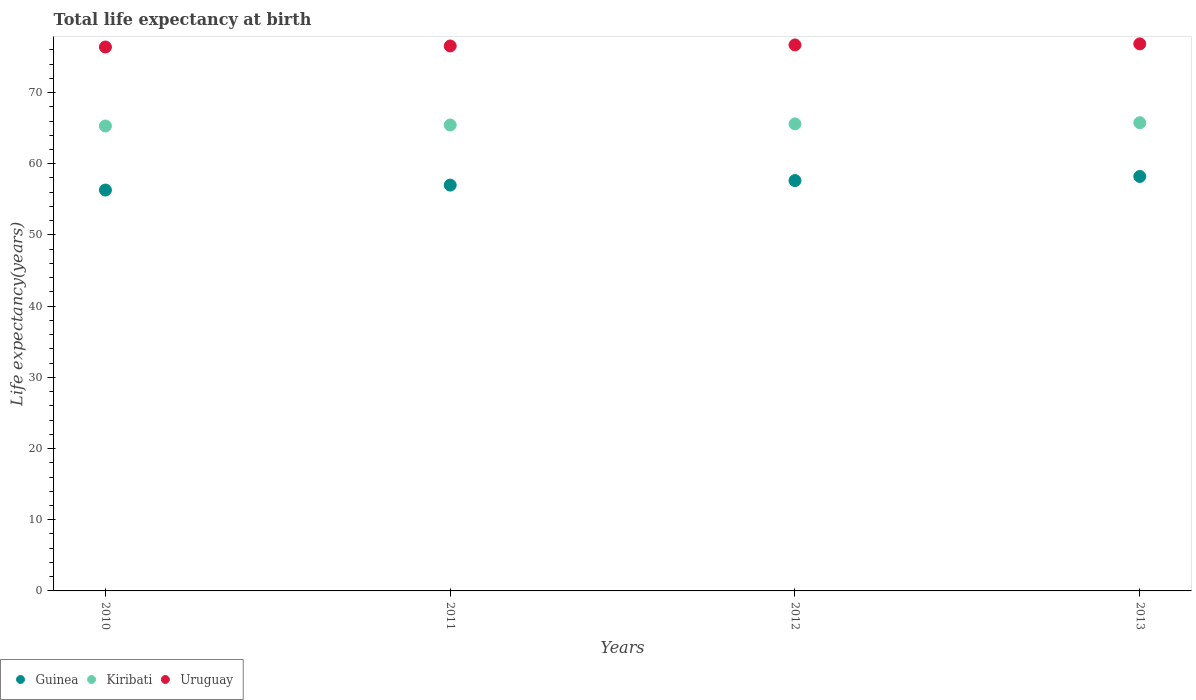What is the life expectancy at birth in in Guinea in 2012?
Make the answer very short. 57.64. Across all years, what is the maximum life expectancy at birth in in Kiribati?
Your answer should be compact. 65.77. Across all years, what is the minimum life expectancy at birth in in Uruguay?
Offer a very short reply. 76.39. In which year was the life expectancy at birth in in Guinea minimum?
Your answer should be compact. 2010. What is the total life expectancy at birth in in Uruguay in the graph?
Your answer should be very brief. 306.46. What is the difference between the life expectancy at birth in in Kiribati in 2010 and that in 2013?
Make the answer very short. -0.46. What is the difference between the life expectancy at birth in in Kiribati in 2011 and the life expectancy at birth in in Uruguay in 2013?
Make the answer very short. -11.4. What is the average life expectancy at birth in in Kiribati per year?
Offer a very short reply. 65.53. In the year 2012, what is the difference between the life expectancy at birth in in Kiribati and life expectancy at birth in in Guinea?
Your answer should be very brief. 7.96. In how many years, is the life expectancy at birth in in Guinea greater than 50 years?
Your response must be concise. 4. What is the ratio of the life expectancy at birth in in Uruguay in 2012 to that in 2013?
Give a very brief answer. 1. Is the life expectancy at birth in in Uruguay in 2012 less than that in 2013?
Your answer should be compact. Yes. What is the difference between the highest and the second highest life expectancy at birth in in Guinea?
Give a very brief answer. 0.58. What is the difference between the highest and the lowest life expectancy at birth in in Uruguay?
Ensure brevity in your answer.  0.44. Is the sum of the life expectancy at birth in in Kiribati in 2010 and 2012 greater than the maximum life expectancy at birth in in Uruguay across all years?
Provide a short and direct response. Yes. How many dotlines are there?
Ensure brevity in your answer.  3. How many years are there in the graph?
Give a very brief answer. 4. What is the difference between two consecutive major ticks on the Y-axis?
Offer a very short reply. 10. Does the graph contain grids?
Offer a very short reply. No. Where does the legend appear in the graph?
Offer a very short reply. Bottom left. How many legend labels are there?
Offer a terse response. 3. How are the legend labels stacked?
Make the answer very short. Horizontal. What is the title of the graph?
Make the answer very short. Total life expectancy at birth. What is the label or title of the Y-axis?
Offer a terse response. Life expectancy(years). What is the Life expectancy(years) in Guinea in 2010?
Your answer should be compact. 56.31. What is the Life expectancy(years) of Kiribati in 2010?
Give a very brief answer. 65.3. What is the Life expectancy(years) of Uruguay in 2010?
Provide a succinct answer. 76.39. What is the Life expectancy(years) in Guinea in 2011?
Your answer should be compact. 57. What is the Life expectancy(years) in Kiribati in 2011?
Keep it short and to the point. 65.44. What is the Life expectancy(years) of Uruguay in 2011?
Make the answer very short. 76.54. What is the Life expectancy(years) in Guinea in 2012?
Provide a short and direct response. 57.64. What is the Life expectancy(years) of Kiribati in 2012?
Your answer should be very brief. 65.6. What is the Life expectancy(years) of Uruguay in 2012?
Ensure brevity in your answer.  76.69. What is the Life expectancy(years) in Guinea in 2013?
Give a very brief answer. 58.22. What is the Life expectancy(years) of Kiribati in 2013?
Offer a terse response. 65.77. What is the Life expectancy(years) of Uruguay in 2013?
Offer a terse response. 76.84. Across all years, what is the maximum Life expectancy(years) in Guinea?
Give a very brief answer. 58.22. Across all years, what is the maximum Life expectancy(years) of Kiribati?
Provide a succinct answer. 65.77. Across all years, what is the maximum Life expectancy(years) of Uruguay?
Your answer should be compact. 76.84. Across all years, what is the minimum Life expectancy(years) in Guinea?
Ensure brevity in your answer.  56.31. Across all years, what is the minimum Life expectancy(years) of Kiribati?
Provide a succinct answer. 65.3. Across all years, what is the minimum Life expectancy(years) in Uruguay?
Provide a short and direct response. 76.39. What is the total Life expectancy(years) of Guinea in the graph?
Provide a succinct answer. 229.16. What is the total Life expectancy(years) of Kiribati in the graph?
Your answer should be very brief. 262.11. What is the total Life expectancy(years) of Uruguay in the graph?
Offer a terse response. 306.46. What is the difference between the Life expectancy(years) of Guinea in 2010 and that in 2011?
Make the answer very short. -0.7. What is the difference between the Life expectancy(years) of Kiribati in 2010 and that in 2011?
Your answer should be compact. -0.14. What is the difference between the Life expectancy(years) of Uruguay in 2010 and that in 2011?
Your answer should be very brief. -0.15. What is the difference between the Life expectancy(years) of Guinea in 2010 and that in 2012?
Your response must be concise. -1.33. What is the difference between the Life expectancy(years) of Kiribati in 2010 and that in 2012?
Ensure brevity in your answer.  -0.29. What is the difference between the Life expectancy(years) of Uruguay in 2010 and that in 2012?
Your answer should be compact. -0.29. What is the difference between the Life expectancy(years) in Guinea in 2010 and that in 2013?
Offer a very short reply. -1.91. What is the difference between the Life expectancy(years) of Kiribati in 2010 and that in 2013?
Your response must be concise. -0.46. What is the difference between the Life expectancy(years) of Uruguay in 2010 and that in 2013?
Your answer should be compact. -0.44. What is the difference between the Life expectancy(years) in Guinea in 2011 and that in 2012?
Offer a terse response. -0.64. What is the difference between the Life expectancy(years) of Kiribati in 2011 and that in 2012?
Your answer should be compact. -0.16. What is the difference between the Life expectancy(years) in Uruguay in 2011 and that in 2012?
Your answer should be very brief. -0.15. What is the difference between the Life expectancy(years) in Guinea in 2011 and that in 2013?
Offer a very short reply. -1.22. What is the difference between the Life expectancy(years) of Kiribati in 2011 and that in 2013?
Ensure brevity in your answer.  -0.33. What is the difference between the Life expectancy(years) in Uruguay in 2011 and that in 2013?
Provide a succinct answer. -0.29. What is the difference between the Life expectancy(years) in Guinea in 2012 and that in 2013?
Provide a short and direct response. -0.58. What is the difference between the Life expectancy(years) of Kiribati in 2012 and that in 2013?
Keep it short and to the point. -0.17. What is the difference between the Life expectancy(years) of Uruguay in 2012 and that in 2013?
Offer a very short reply. -0.15. What is the difference between the Life expectancy(years) in Guinea in 2010 and the Life expectancy(years) in Kiribati in 2011?
Offer a very short reply. -9.14. What is the difference between the Life expectancy(years) in Guinea in 2010 and the Life expectancy(years) in Uruguay in 2011?
Give a very brief answer. -20.24. What is the difference between the Life expectancy(years) of Kiribati in 2010 and the Life expectancy(years) of Uruguay in 2011?
Your response must be concise. -11.24. What is the difference between the Life expectancy(years) of Guinea in 2010 and the Life expectancy(years) of Kiribati in 2012?
Keep it short and to the point. -9.29. What is the difference between the Life expectancy(years) in Guinea in 2010 and the Life expectancy(years) in Uruguay in 2012?
Your answer should be very brief. -20.38. What is the difference between the Life expectancy(years) of Kiribati in 2010 and the Life expectancy(years) of Uruguay in 2012?
Make the answer very short. -11.39. What is the difference between the Life expectancy(years) of Guinea in 2010 and the Life expectancy(years) of Kiribati in 2013?
Give a very brief answer. -9.46. What is the difference between the Life expectancy(years) in Guinea in 2010 and the Life expectancy(years) in Uruguay in 2013?
Keep it short and to the point. -20.53. What is the difference between the Life expectancy(years) in Kiribati in 2010 and the Life expectancy(years) in Uruguay in 2013?
Ensure brevity in your answer.  -11.53. What is the difference between the Life expectancy(years) in Guinea in 2011 and the Life expectancy(years) in Kiribati in 2012?
Give a very brief answer. -8.6. What is the difference between the Life expectancy(years) of Guinea in 2011 and the Life expectancy(years) of Uruguay in 2012?
Keep it short and to the point. -19.69. What is the difference between the Life expectancy(years) in Kiribati in 2011 and the Life expectancy(years) in Uruguay in 2012?
Provide a short and direct response. -11.25. What is the difference between the Life expectancy(years) in Guinea in 2011 and the Life expectancy(years) in Kiribati in 2013?
Your answer should be compact. -8.77. What is the difference between the Life expectancy(years) of Guinea in 2011 and the Life expectancy(years) of Uruguay in 2013?
Your answer should be compact. -19.84. What is the difference between the Life expectancy(years) of Kiribati in 2011 and the Life expectancy(years) of Uruguay in 2013?
Your response must be concise. -11.4. What is the difference between the Life expectancy(years) of Guinea in 2012 and the Life expectancy(years) of Kiribati in 2013?
Your answer should be very brief. -8.13. What is the difference between the Life expectancy(years) in Guinea in 2012 and the Life expectancy(years) in Uruguay in 2013?
Make the answer very short. -19.2. What is the difference between the Life expectancy(years) of Kiribati in 2012 and the Life expectancy(years) of Uruguay in 2013?
Ensure brevity in your answer.  -11.24. What is the average Life expectancy(years) in Guinea per year?
Your answer should be very brief. 57.29. What is the average Life expectancy(years) in Kiribati per year?
Give a very brief answer. 65.53. What is the average Life expectancy(years) of Uruguay per year?
Make the answer very short. 76.62. In the year 2010, what is the difference between the Life expectancy(years) of Guinea and Life expectancy(years) of Kiribati?
Keep it short and to the point. -9. In the year 2010, what is the difference between the Life expectancy(years) in Guinea and Life expectancy(years) in Uruguay?
Provide a succinct answer. -20.09. In the year 2010, what is the difference between the Life expectancy(years) in Kiribati and Life expectancy(years) in Uruguay?
Offer a terse response. -11.09. In the year 2011, what is the difference between the Life expectancy(years) in Guinea and Life expectancy(years) in Kiribati?
Provide a short and direct response. -8.44. In the year 2011, what is the difference between the Life expectancy(years) of Guinea and Life expectancy(years) of Uruguay?
Offer a terse response. -19.54. In the year 2011, what is the difference between the Life expectancy(years) in Kiribati and Life expectancy(years) in Uruguay?
Give a very brief answer. -11.1. In the year 2012, what is the difference between the Life expectancy(years) in Guinea and Life expectancy(years) in Kiribati?
Your answer should be very brief. -7.96. In the year 2012, what is the difference between the Life expectancy(years) of Guinea and Life expectancy(years) of Uruguay?
Your answer should be compact. -19.05. In the year 2012, what is the difference between the Life expectancy(years) in Kiribati and Life expectancy(years) in Uruguay?
Ensure brevity in your answer.  -11.09. In the year 2013, what is the difference between the Life expectancy(years) of Guinea and Life expectancy(years) of Kiribati?
Keep it short and to the point. -7.55. In the year 2013, what is the difference between the Life expectancy(years) in Guinea and Life expectancy(years) in Uruguay?
Offer a very short reply. -18.62. In the year 2013, what is the difference between the Life expectancy(years) in Kiribati and Life expectancy(years) in Uruguay?
Keep it short and to the point. -11.07. What is the ratio of the Life expectancy(years) in Kiribati in 2010 to that in 2011?
Provide a short and direct response. 1. What is the ratio of the Life expectancy(years) of Uruguay in 2010 to that in 2011?
Your response must be concise. 1. What is the ratio of the Life expectancy(years) in Guinea in 2010 to that in 2012?
Your answer should be compact. 0.98. What is the ratio of the Life expectancy(years) in Uruguay in 2010 to that in 2012?
Make the answer very short. 1. What is the ratio of the Life expectancy(years) in Guinea in 2010 to that in 2013?
Make the answer very short. 0.97. What is the ratio of the Life expectancy(years) of Guinea in 2011 to that in 2012?
Your response must be concise. 0.99. What is the ratio of the Life expectancy(years) in Guinea in 2011 to that in 2013?
Your answer should be compact. 0.98. What is the ratio of the Life expectancy(years) of Kiribati in 2012 to that in 2013?
Your answer should be very brief. 1. What is the ratio of the Life expectancy(years) in Uruguay in 2012 to that in 2013?
Keep it short and to the point. 1. What is the difference between the highest and the second highest Life expectancy(years) of Guinea?
Your answer should be very brief. 0.58. What is the difference between the highest and the second highest Life expectancy(years) in Kiribati?
Keep it short and to the point. 0.17. What is the difference between the highest and the second highest Life expectancy(years) in Uruguay?
Give a very brief answer. 0.15. What is the difference between the highest and the lowest Life expectancy(years) of Guinea?
Your response must be concise. 1.91. What is the difference between the highest and the lowest Life expectancy(years) of Kiribati?
Offer a very short reply. 0.46. What is the difference between the highest and the lowest Life expectancy(years) of Uruguay?
Ensure brevity in your answer.  0.44. 